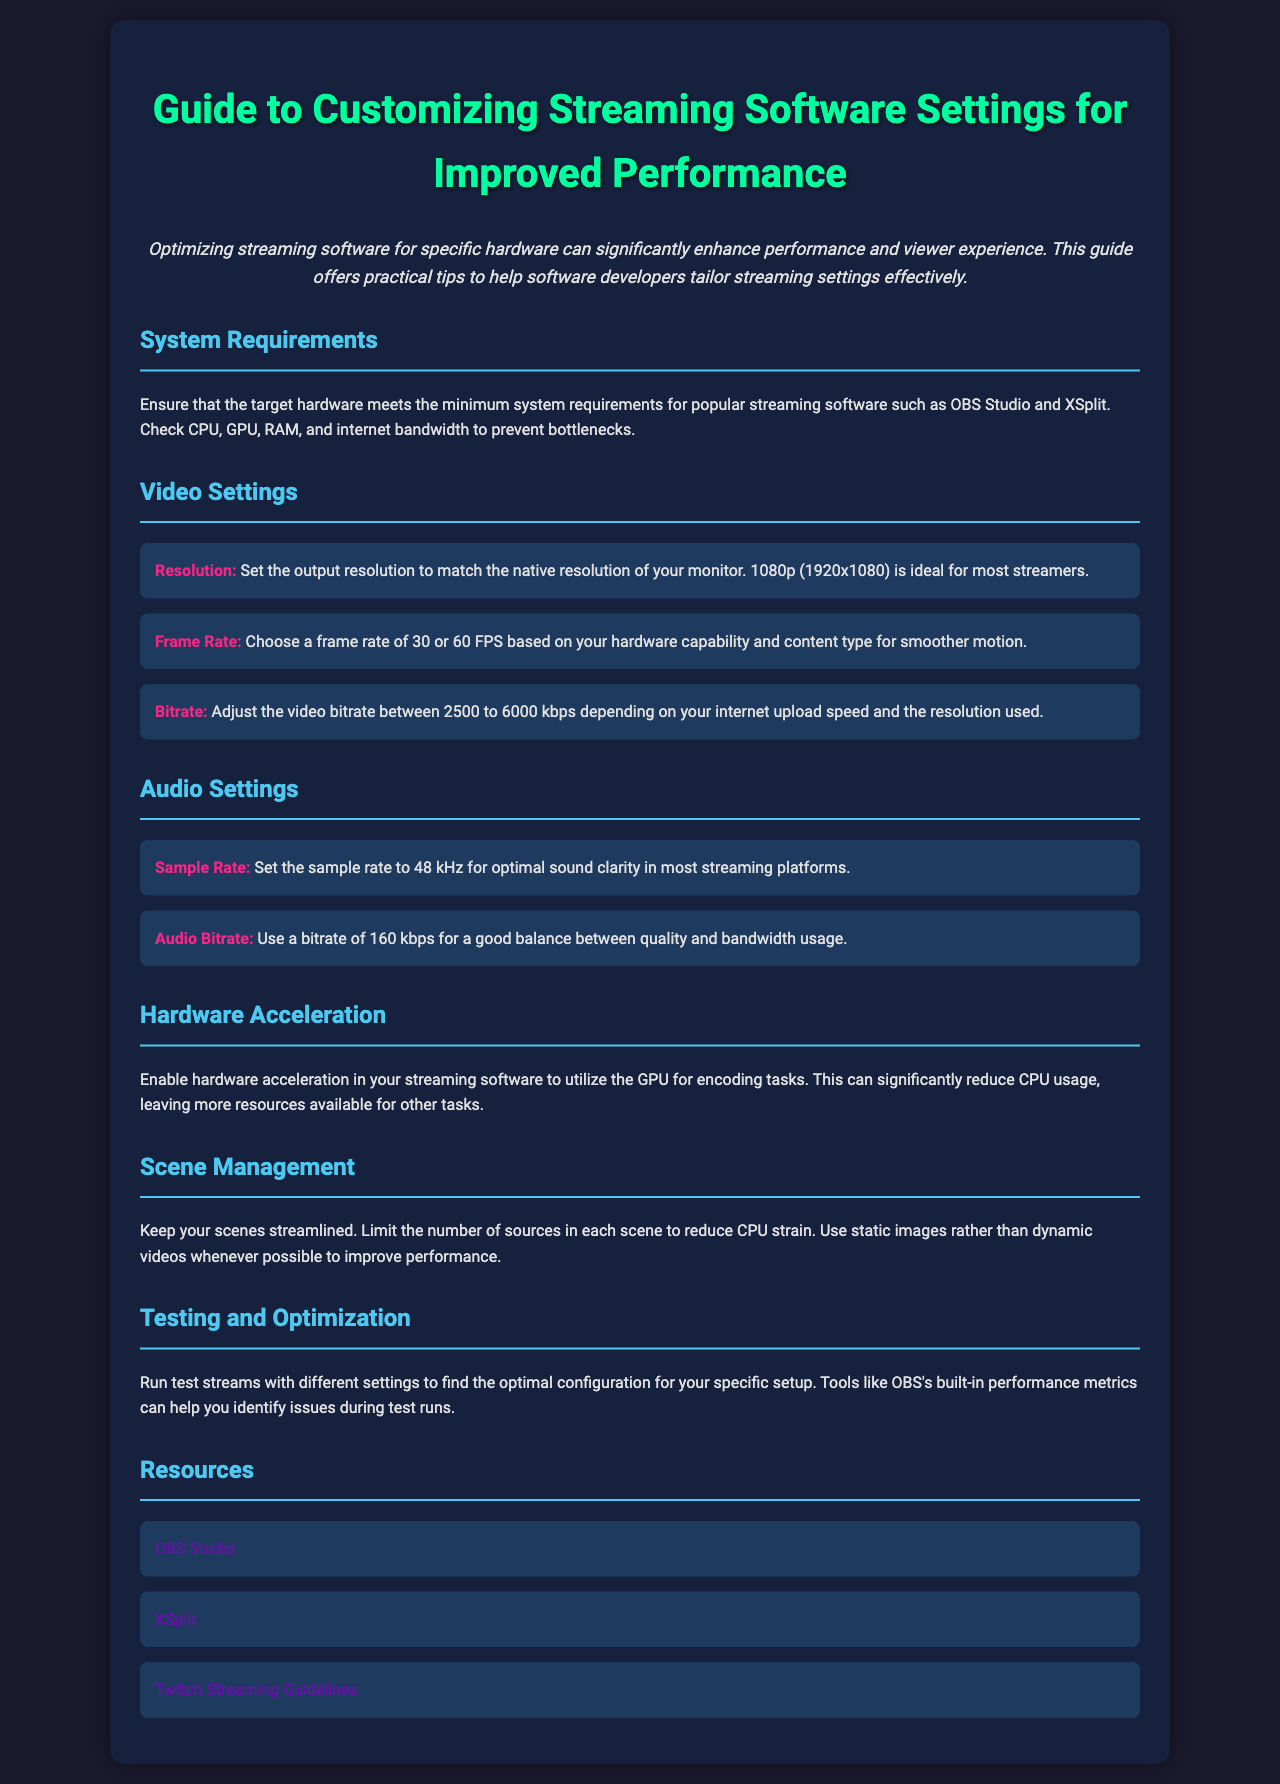what is the ideal output resolution for most streamers? The document states that 1080p (1920x1080) is ideal for most streamers.
Answer: 1080p (1920x1080) what frame rate should be chosen for smoother motion? The document recommends a frame rate of 30 or 60 FPS for smoother motion.
Answer: 30 or 60 FPS what should be the audio sample rate for optimal sound clarity? The document specifies that the sample rate should be set to 48 kHz.
Answer: 48 kHz what is the recommended range for video bitrate? The document advises adjusting the video bitrate between 2500 to 6000 kbps.
Answer: 2500 to 6000 kbps how can hardware acceleration affect CPU usage? The document mentions that enabling hardware acceleration can significantly reduce CPU usage.
Answer: reduce CPU usage what is a good audio bitrate for balance between quality and bandwidth? The document suggests using a bitrate of 160 kbps for a good balance.
Answer: 160 kbps what should be minimized in scene management for performance? The text indicates to limit the number of sources in each scene to reduce CPU strain.
Answer: number of sources how can test streams assist in optimizing settings? The document states that test streams can help to find the optimal configuration for your specific setup.
Answer: find optimal configuration which streaming software is mentioned for community guidelines? The document references Twitch for streaming guidelines.
Answer: Twitch 